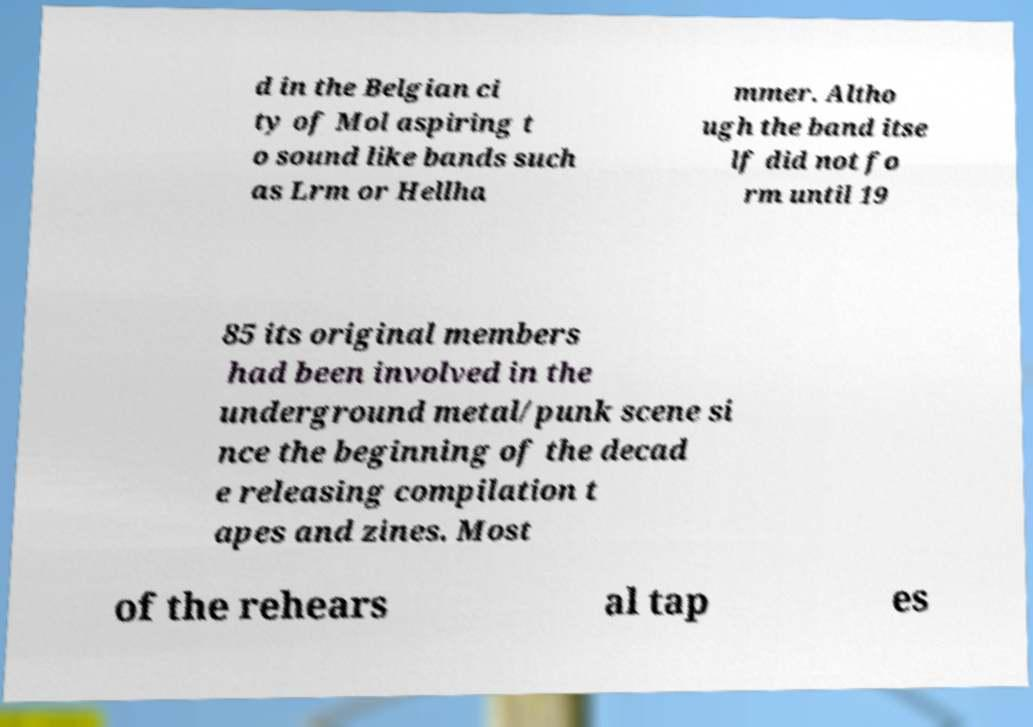Could you extract and type out the text from this image? d in the Belgian ci ty of Mol aspiring t o sound like bands such as Lrm or Hellha mmer. Altho ugh the band itse lf did not fo rm until 19 85 its original members had been involved in the underground metal/punk scene si nce the beginning of the decad e releasing compilation t apes and zines. Most of the rehears al tap es 